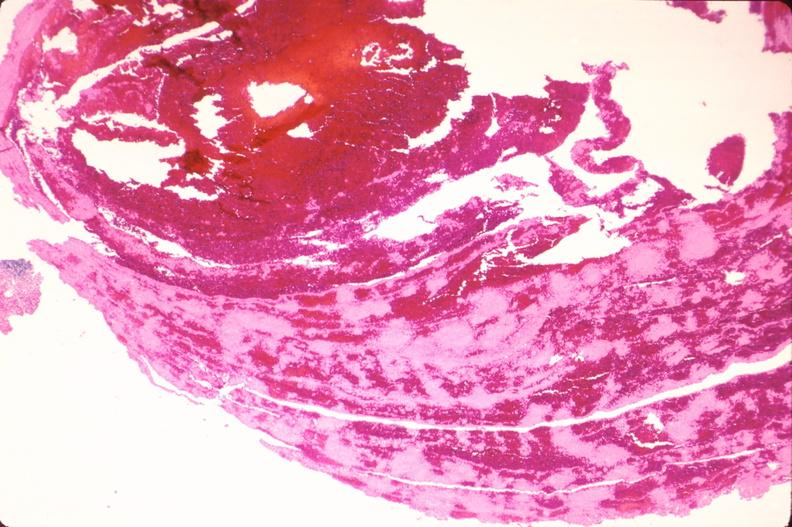does this image show thromboembolus from leg veins in pulmonary artery?
Answer the question using a single word or phrase. Yes 